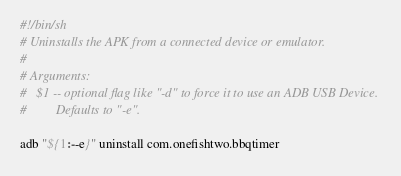<code> <loc_0><loc_0><loc_500><loc_500><_Bash_>#!/bin/sh
# Uninstalls the APK from a connected device or emulator.
#
# Arguments:
#   $1 -- optional flag like "-d" to force it to use an ADB USB Device.
#         Defaults to "-e".

adb "${1:--e}" uninstall com.onefishtwo.bbqtimer
</code> 